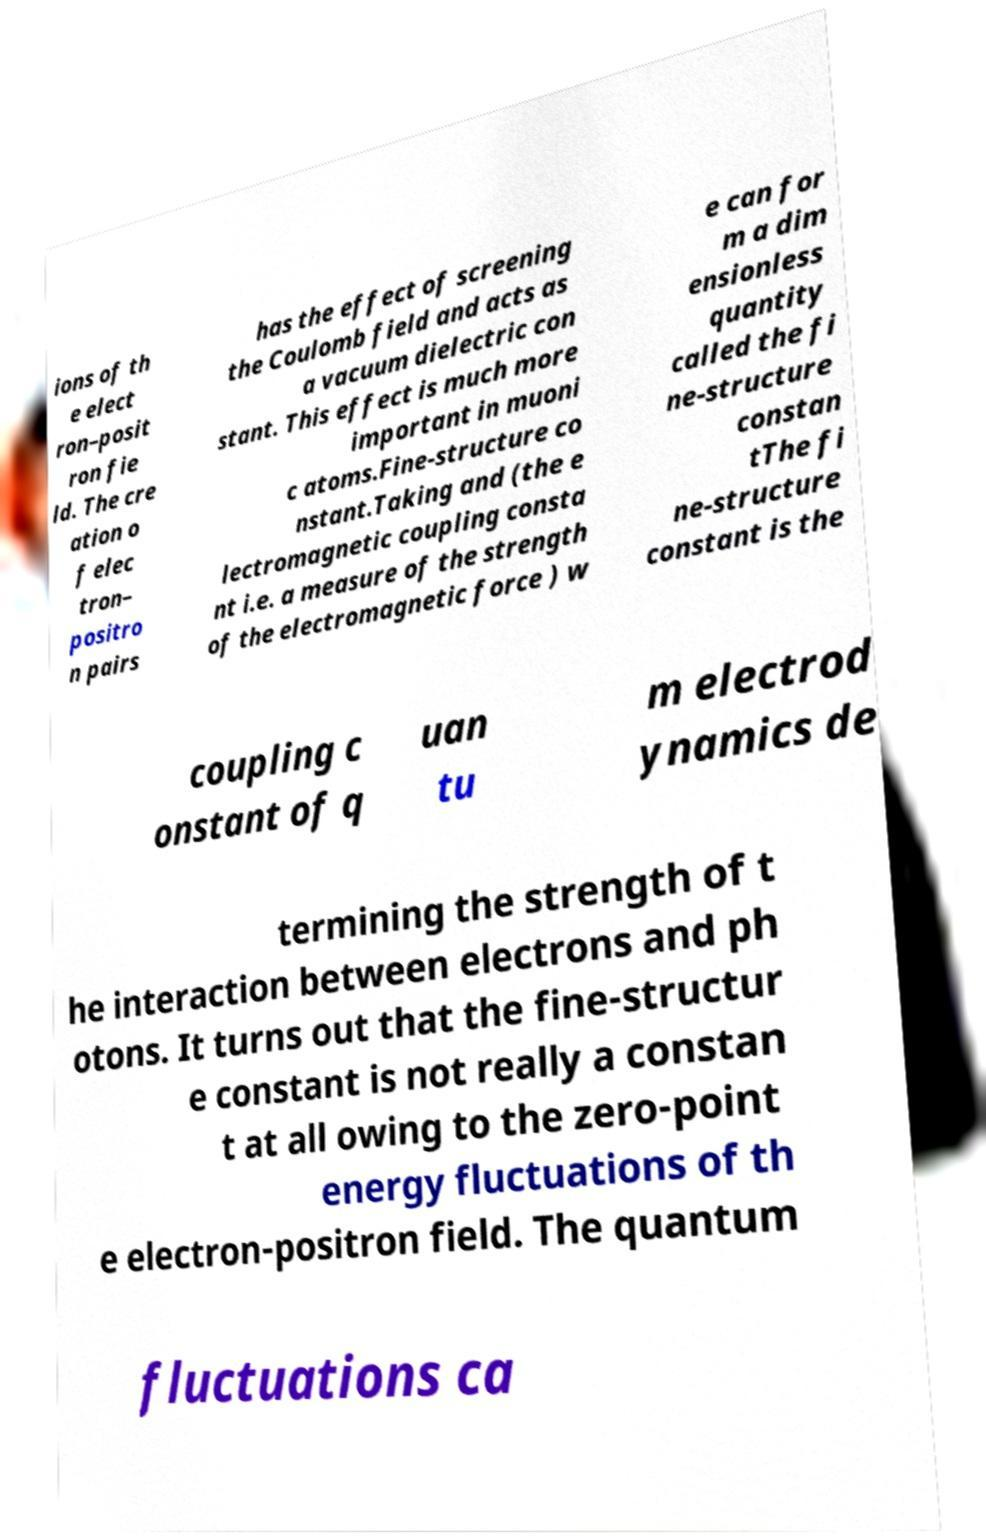Please read and relay the text visible in this image. What does it say? ions of th e elect ron–posit ron fie ld. The cre ation o f elec tron– positro n pairs has the effect of screening the Coulomb field and acts as a vacuum dielectric con stant. This effect is much more important in muoni c atoms.Fine-structure co nstant.Taking and (the e lectromagnetic coupling consta nt i.e. a measure of the strength of the electromagnetic force ) w e can for m a dim ensionless quantity called the fi ne-structure constan tThe fi ne-structure constant is the coupling c onstant of q uan tu m electrod ynamics de termining the strength of t he interaction between electrons and ph otons. It turns out that the fine-structur e constant is not really a constan t at all owing to the zero-point energy fluctuations of th e electron-positron field. The quantum fluctuations ca 